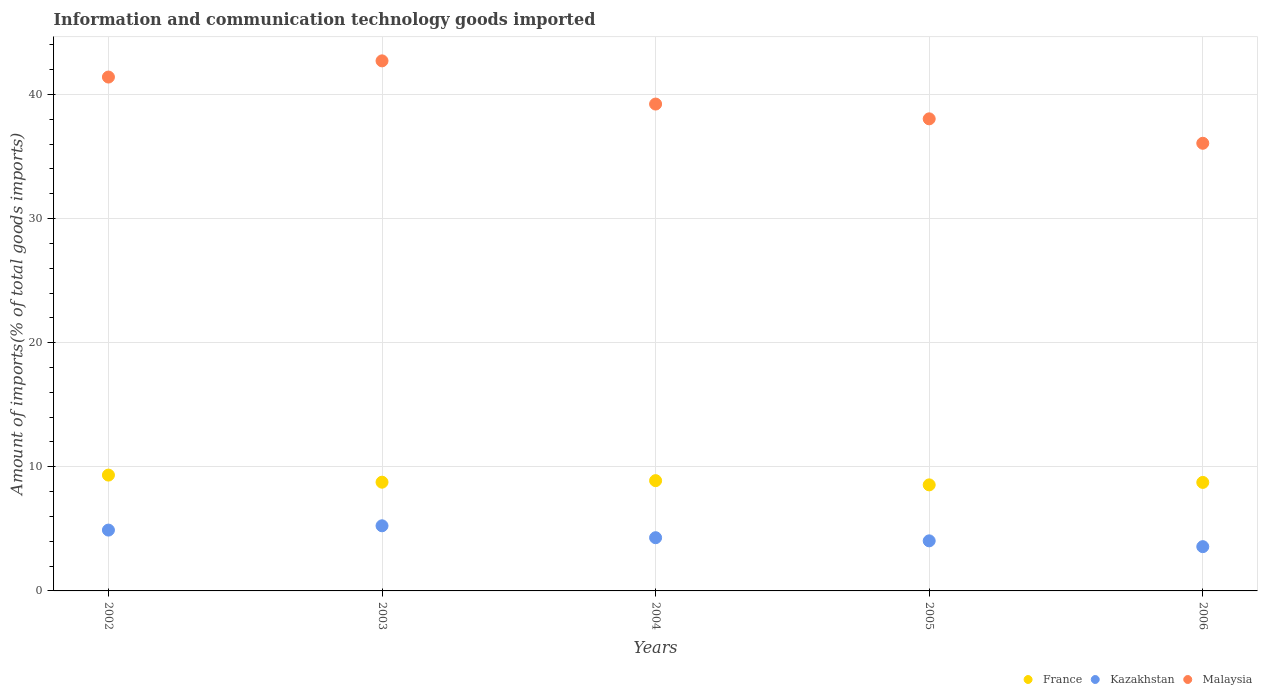How many different coloured dotlines are there?
Your answer should be very brief. 3. Is the number of dotlines equal to the number of legend labels?
Provide a short and direct response. Yes. What is the amount of goods imported in Kazakhstan in 2004?
Keep it short and to the point. 4.29. Across all years, what is the maximum amount of goods imported in Kazakhstan?
Your answer should be very brief. 5.25. Across all years, what is the minimum amount of goods imported in France?
Keep it short and to the point. 8.54. In which year was the amount of goods imported in France maximum?
Ensure brevity in your answer.  2002. In which year was the amount of goods imported in Kazakhstan minimum?
Make the answer very short. 2006. What is the total amount of goods imported in Kazakhstan in the graph?
Offer a very short reply. 22.04. What is the difference between the amount of goods imported in France in 2002 and that in 2003?
Give a very brief answer. 0.57. What is the difference between the amount of goods imported in France in 2003 and the amount of goods imported in Malaysia in 2005?
Your answer should be very brief. -29.28. What is the average amount of goods imported in France per year?
Keep it short and to the point. 8.85. In the year 2005, what is the difference between the amount of goods imported in France and amount of goods imported in Malaysia?
Keep it short and to the point. -29.49. In how many years, is the amount of goods imported in Kazakhstan greater than 6 %?
Provide a short and direct response. 0. What is the ratio of the amount of goods imported in France in 2003 to that in 2006?
Your answer should be compact. 1. Is the amount of goods imported in Kazakhstan in 2002 less than that in 2006?
Provide a short and direct response. No. What is the difference between the highest and the second highest amount of goods imported in Kazakhstan?
Keep it short and to the point. 0.35. What is the difference between the highest and the lowest amount of goods imported in Kazakhstan?
Provide a short and direct response. 1.68. In how many years, is the amount of goods imported in Kazakhstan greater than the average amount of goods imported in Kazakhstan taken over all years?
Make the answer very short. 2. Is it the case that in every year, the sum of the amount of goods imported in Malaysia and amount of goods imported in Kazakhstan  is greater than the amount of goods imported in France?
Make the answer very short. Yes. Does the amount of goods imported in France monotonically increase over the years?
Offer a very short reply. No. Is the amount of goods imported in Kazakhstan strictly greater than the amount of goods imported in Malaysia over the years?
Ensure brevity in your answer.  No. How many years are there in the graph?
Ensure brevity in your answer.  5. What is the difference between two consecutive major ticks on the Y-axis?
Your answer should be compact. 10. Does the graph contain grids?
Provide a succinct answer. Yes. Where does the legend appear in the graph?
Offer a very short reply. Bottom right. What is the title of the graph?
Keep it short and to the point. Information and communication technology goods imported. Does "France" appear as one of the legend labels in the graph?
Provide a short and direct response. Yes. What is the label or title of the X-axis?
Ensure brevity in your answer.  Years. What is the label or title of the Y-axis?
Keep it short and to the point. Amount of imports(% of total goods imports). What is the Amount of imports(% of total goods imports) in France in 2002?
Provide a succinct answer. 9.33. What is the Amount of imports(% of total goods imports) in Kazakhstan in 2002?
Make the answer very short. 4.9. What is the Amount of imports(% of total goods imports) of Malaysia in 2002?
Offer a terse response. 41.4. What is the Amount of imports(% of total goods imports) of France in 2003?
Your answer should be compact. 8.76. What is the Amount of imports(% of total goods imports) of Kazakhstan in 2003?
Offer a very short reply. 5.25. What is the Amount of imports(% of total goods imports) of Malaysia in 2003?
Offer a very short reply. 42.71. What is the Amount of imports(% of total goods imports) of France in 2004?
Your answer should be compact. 8.89. What is the Amount of imports(% of total goods imports) in Kazakhstan in 2004?
Give a very brief answer. 4.29. What is the Amount of imports(% of total goods imports) of Malaysia in 2004?
Ensure brevity in your answer.  39.23. What is the Amount of imports(% of total goods imports) in France in 2005?
Offer a very short reply. 8.54. What is the Amount of imports(% of total goods imports) of Kazakhstan in 2005?
Your answer should be compact. 4.03. What is the Amount of imports(% of total goods imports) of Malaysia in 2005?
Offer a terse response. 38.04. What is the Amount of imports(% of total goods imports) of France in 2006?
Your response must be concise. 8.74. What is the Amount of imports(% of total goods imports) in Kazakhstan in 2006?
Provide a short and direct response. 3.57. What is the Amount of imports(% of total goods imports) in Malaysia in 2006?
Keep it short and to the point. 36.07. Across all years, what is the maximum Amount of imports(% of total goods imports) of France?
Make the answer very short. 9.33. Across all years, what is the maximum Amount of imports(% of total goods imports) in Kazakhstan?
Keep it short and to the point. 5.25. Across all years, what is the maximum Amount of imports(% of total goods imports) in Malaysia?
Your answer should be compact. 42.71. Across all years, what is the minimum Amount of imports(% of total goods imports) of France?
Keep it short and to the point. 8.54. Across all years, what is the minimum Amount of imports(% of total goods imports) in Kazakhstan?
Keep it short and to the point. 3.57. Across all years, what is the minimum Amount of imports(% of total goods imports) of Malaysia?
Your answer should be very brief. 36.07. What is the total Amount of imports(% of total goods imports) of France in the graph?
Provide a succinct answer. 44.27. What is the total Amount of imports(% of total goods imports) in Kazakhstan in the graph?
Your answer should be very brief. 22.04. What is the total Amount of imports(% of total goods imports) of Malaysia in the graph?
Provide a succinct answer. 197.45. What is the difference between the Amount of imports(% of total goods imports) of France in 2002 and that in 2003?
Keep it short and to the point. 0.57. What is the difference between the Amount of imports(% of total goods imports) in Kazakhstan in 2002 and that in 2003?
Your response must be concise. -0.35. What is the difference between the Amount of imports(% of total goods imports) in Malaysia in 2002 and that in 2003?
Make the answer very short. -1.3. What is the difference between the Amount of imports(% of total goods imports) of France in 2002 and that in 2004?
Provide a succinct answer. 0.45. What is the difference between the Amount of imports(% of total goods imports) of Kazakhstan in 2002 and that in 2004?
Your answer should be very brief. 0.61. What is the difference between the Amount of imports(% of total goods imports) in Malaysia in 2002 and that in 2004?
Make the answer very short. 2.18. What is the difference between the Amount of imports(% of total goods imports) of France in 2002 and that in 2005?
Your answer should be compact. 0.79. What is the difference between the Amount of imports(% of total goods imports) in Kazakhstan in 2002 and that in 2005?
Your answer should be compact. 0.87. What is the difference between the Amount of imports(% of total goods imports) of Malaysia in 2002 and that in 2005?
Your response must be concise. 3.37. What is the difference between the Amount of imports(% of total goods imports) in France in 2002 and that in 2006?
Keep it short and to the point. 0.59. What is the difference between the Amount of imports(% of total goods imports) of Kazakhstan in 2002 and that in 2006?
Give a very brief answer. 1.33. What is the difference between the Amount of imports(% of total goods imports) in Malaysia in 2002 and that in 2006?
Keep it short and to the point. 5.34. What is the difference between the Amount of imports(% of total goods imports) of France in 2003 and that in 2004?
Provide a succinct answer. -0.12. What is the difference between the Amount of imports(% of total goods imports) in Kazakhstan in 2003 and that in 2004?
Keep it short and to the point. 0.96. What is the difference between the Amount of imports(% of total goods imports) of Malaysia in 2003 and that in 2004?
Provide a succinct answer. 3.48. What is the difference between the Amount of imports(% of total goods imports) in France in 2003 and that in 2005?
Your answer should be very brief. 0.22. What is the difference between the Amount of imports(% of total goods imports) of Kazakhstan in 2003 and that in 2005?
Your answer should be very brief. 1.21. What is the difference between the Amount of imports(% of total goods imports) in Malaysia in 2003 and that in 2005?
Provide a short and direct response. 4.67. What is the difference between the Amount of imports(% of total goods imports) of France in 2003 and that in 2006?
Provide a succinct answer. 0.02. What is the difference between the Amount of imports(% of total goods imports) of Kazakhstan in 2003 and that in 2006?
Your response must be concise. 1.68. What is the difference between the Amount of imports(% of total goods imports) in Malaysia in 2003 and that in 2006?
Provide a succinct answer. 6.64. What is the difference between the Amount of imports(% of total goods imports) of France in 2004 and that in 2005?
Ensure brevity in your answer.  0.34. What is the difference between the Amount of imports(% of total goods imports) in Kazakhstan in 2004 and that in 2005?
Provide a short and direct response. 0.25. What is the difference between the Amount of imports(% of total goods imports) of Malaysia in 2004 and that in 2005?
Offer a terse response. 1.19. What is the difference between the Amount of imports(% of total goods imports) of France in 2004 and that in 2006?
Ensure brevity in your answer.  0.14. What is the difference between the Amount of imports(% of total goods imports) in Kazakhstan in 2004 and that in 2006?
Provide a succinct answer. 0.72. What is the difference between the Amount of imports(% of total goods imports) of Malaysia in 2004 and that in 2006?
Your answer should be very brief. 3.16. What is the difference between the Amount of imports(% of total goods imports) of France in 2005 and that in 2006?
Your answer should be compact. -0.2. What is the difference between the Amount of imports(% of total goods imports) of Kazakhstan in 2005 and that in 2006?
Provide a short and direct response. 0.47. What is the difference between the Amount of imports(% of total goods imports) in Malaysia in 2005 and that in 2006?
Provide a short and direct response. 1.97. What is the difference between the Amount of imports(% of total goods imports) of France in 2002 and the Amount of imports(% of total goods imports) of Kazakhstan in 2003?
Offer a terse response. 4.09. What is the difference between the Amount of imports(% of total goods imports) of France in 2002 and the Amount of imports(% of total goods imports) of Malaysia in 2003?
Offer a terse response. -33.38. What is the difference between the Amount of imports(% of total goods imports) in Kazakhstan in 2002 and the Amount of imports(% of total goods imports) in Malaysia in 2003?
Provide a short and direct response. -37.81. What is the difference between the Amount of imports(% of total goods imports) in France in 2002 and the Amount of imports(% of total goods imports) in Kazakhstan in 2004?
Offer a terse response. 5.05. What is the difference between the Amount of imports(% of total goods imports) of France in 2002 and the Amount of imports(% of total goods imports) of Malaysia in 2004?
Offer a very short reply. -29.9. What is the difference between the Amount of imports(% of total goods imports) in Kazakhstan in 2002 and the Amount of imports(% of total goods imports) in Malaysia in 2004?
Provide a short and direct response. -34.33. What is the difference between the Amount of imports(% of total goods imports) of France in 2002 and the Amount of imports(% of total goods imports) of Kazakhstan in 2005?
Make the answer very short. 5.3. What is the difference between the Amount of imports(% of total goods imports) of France in 2002 and the Amount of imports(% of total goods imports) of Malaysia in 2005?
Offer a terse response. -28.7. What is the difference between the Amount of imports(% of total goods imports) of Kazakhstan in 2002 and the Amount of imports(% of total goods imports) of Malaysia in 2005?
Give a very brief answer. -33.14. What is the difference between the Amount of imports(% of total goods imports) of France in 2002 and the Amount of imports(% of total goods imports) of Kazakhstan in 2006?
Offer a terse response. 5.77. What is the difference between the Amount of imports(% of total goods imports) in France in 2002 and the Amount of imports(% of total goods imports) in Malaysia in 2006?
Your answer should be compact. -26.74. What is the difference between the Amount of imports(% of total goods imports) in Kazakhstan in 2002 and the Amount of imports(% of total goods imports) in Malaysia in 2006?
Give a very brief answer. -31.17. What is the difference between the Amount of imports(% of total goods imports) of France in 2003 and the Amount of imports(% of total goods imports) of Kazakhstan in 2004?
Keep it short and to the point. 4.47. What is the difference between the Amount of imports(% of total goods imports) in France in 2003 and the Amount of imports(% of total goods imports) in Malaysia in 2004?
Ensure brevity in your answer.  -30.47. What is the difference between the Amount of imports(% of total goods imports) of Kazakhstan in 2003 and the Amount of imports(% of total goods imports) of Malaysia in 2004?
Offer a terse response. -33.98. What is the difference between the Amount of imports(% of total goods imports) of France in 2003 and the Amount of imports(% of total goods imports) of Kazakhstan in 2005?
Keep it short and to the point. 4.73. What is the difference between the Amount of imports(% of total goods imports) in France in 2003 and the Amount of imports(% of total goods imports) in Malaysia in 2005?
Your answer should be compact. -29.28. What is the difference between the Amount of imports(% of total goods imports) of Kazakhstan in 2003 and the Amount of imports(% of total goods imports) of Malaysia in 2005?
Your response must be concise. -32.79. What is the difference between the Amount of imports(% of total goods imports) of France in 2003 and the Amount of imports(% of total goods imports) of Kazakhstan in 2006?
Offer a terse response. 5.19. What is the difference between the Amount of imports(% of total goods imports) in France in 2003 and the Amount of imports(% of total goods imports) in Malaysia in 2006?
Make the answer very short. -27.31. What is the difference between the Amount of imports(% of total goods imports) of Kazakhstan in 2003 and the Amount of imports(% of total goods imports) of Malaysia in 2006?
Your answer should be compact. -30.82. What is the difference between the Amount of imports(% of total goods imports) of France in 2004 and the Amount of imports(% of total goods imports) of Kazakhstan in 2005?
Offer a very short reply. 4.85. What is the difference between the Amount of imports(% of total goods imports) of France in 2004 and the Amount of imports(% of total goods imports) of Malaysia in 2005?
Offer a terse response. -29.15. What is the difference between the Amount of imports(% of total goods imports) in Kazakhstan in 2004 and the Amount of imports(% of total goods imports) in Malaysia in 2005?
Ensure brevity in your answer.  -33.75. What is the difference between the Amount of imports(% of total goods imports) in France in 2004 and the Amount of imports(% of total goods imports) in Kazakhstan in 2006?
Offer a very short reply. 5.32. What is the difference between the Amount of imports(% of total goods imports) of France in 2004 and the Amount of imports(% of total goods imports) of Malaysia in 2006?
Make the answer very short. -27.18. What is the difference between the Amount of imports(% of total goods imports) in Kazakhstan in 2004 and the Amount of imports(% of total goods imports) in Malaysia in 2006?
Your answer should be compact. -31.78. What is the difference between the Amount of imports(% of total goods imports) in France in 2005 and the Amount of imports(% of total goods imports) in Kazakhstan in 2006?
Your answer should be compact. 4.98. What is the difference between the Amount of imports(% of total goods imports) of France in 2005 and the Amount of imports(% of total goods imports) of Malaysia in 2006?
Provide a short and direct response. -27.52. What is the difference between the Amount of imports(% of total goods imports) in Kazakhstan in 2005 and the Amount of imports(% of total goods imports) in Malaysia in 2006?
Provide a short and direct response. -32.03. What is the average Amount of imports(% of total goods imports) in France per year?
Offer a terse response. 8.85. What is the average Amount of imports(% of total goods imports) in Kazakhstan per year?
Your answer should be compact. 4.41. What is the average Amount of imports(% of total goods imports) in Malaysia per year?
Give a very brief answer. 39.49. In the year 2002, what is the difference between the Amount of imports(% of total goods imports) of France and Amount of imports(% of total goods imports) of Kazakhstan?
Ensure brevity in your answer.  4.43. In the year 2002, what is the difference between the Amount of imports(% of total goods imports) of France and Amount of imports(% of total goods imports) of Malaysia?
Offer a terse response. -32.07. In the year 2002, what is the difference between the Amount of imports(% of total goods imports) in Kazakhstan and Amount of imports(% of total goods imports) in Malaysia?
Make the answer very short. -36.5. In the year 2003, what is the difference between the Amount of imports(% of total goods imports) in France and Amount of imports(% of total goods imports) in Kazakhstan?
Give a very brief answer. 3.51. In the year 2003, what is the difference between the Amount of imports(% of total goods imports) in France and Amount of imports(% of total goods imports) in Malaysia?
Offer a terse response. -33.95. In the year 2003, what is the difference between the Amount of imports(% of total goods imports) of Kazakhstan and Amount of imports(% of total goods imports) of Malaysia?
Offer a very short reply. -37.46. In the year 2004, what is the difference between the Amount of imports(% of total goods imports) in France and Amount of imports(% of total goods imports) in Kazakhstan?
Ensure brevity in your answer.  4.6. In the year 2004, what is the difference between the Amount of imports(% of total goods imports) of France and Amount of imports(% of total goods imports) of Malaysia?
Your answer should be compact. -30.34. In the year 2004, what is the difference between the Amount of imports(% of total goods imports) of Kazakhstan and Amount of imports(% of total goods imports) of Malaysia?
Your response must be concise. -34.94. In the year 2005, what is the difference between the Amount of imports(% of total goods imports) of France and Amount of imports(% of total goods imports) of Kazakhstan?
Offer a very short reply. 4.51. In the year 2005, what is the difference between the Amount of imports(% of total goods imports) of France and Amount of imports(% of total goods imports) of Malaysia?
Keep it short and to the point. -29.49. In the year 2005, what is the difference between the Amount of imports(% of total goods imports) in Kazakhstan and Amount of imports(% of total goods imports) in Malaysia?
Ensure brevity in your answer.  -34. In the year 2006, what is the difference between the Amount of imports(% of total goods imports) of France and Amount of imports(% of total goods imports) of Kazakhstan?
Give a very brief answer. 5.18. In the year 2006, what is the difference between the Amount of imports(% of total goods imports) of France and Amount of imports(% of total goods imports) of Malaysia?
Provide a short and direct response. -27.33. In the year 2006, what is the difference between the Amount of imports(% of total goods imports) in Kazakhstan and Amount of imports(% of total goods imports) in Malaysia?
Your answer should be very brief. -32.5. What is the ratio of the Amount of imports(% of total goods imports) of France in 2002 to that in 2003?
Your response must be concise. 1.07. What is the ratio of the Amount of imports(% of total goods imports) of Kazakhstan in 2002 to that in 2003?
Offer a very short reply. 0.93. What is the ratio of the Amount of imports(% of total goods imports) in Malaysia in 2002 to that in 2003?
Provide a short and direct response. 0.97. What is the ratio of the Amount of imports(% of total goods imports) of France in 2002 to that in 2004?
Your response must be concise. 1.05. What is the ratio of the Amount of imports(% of total goods imports) in Kazakhstan in 2002 to that in 2004?
Offer a terse response. 1.14. What is the ratio of the Amount of imports(% of total goods imports) in Malaysia in 2002 to that in 2004?
Offer a terse response. 1.06. What is the ratio of the Amount of imports(% of total goods imports) of France in 2002 to that in 2005?
Provide a succinct answer. 1.09. What is the ratio of the Amount of imports(% of total goods imports) in Kazakhstan in 2002 to that in 2005?
Your answer should be very brief. 1.21. What is the ratio of the Amount of imports(% of total goods imports) in Malaysia in 2002 to that in 2005?
Offer a very short reply. 1.09. What is the ratio of the Amount of imports(% of total goods imports) in France in 2002 to that in 2006?
Provide a short and direct response. 1.07. What is the ratio of the Amount of imports(% of total goods imports) in Kazakhstan in 2002 to that in 2006?
Your response must be concise. 1.37. What is the ratio of the Amount of imports(% of total goods imports) of Malaysia in 2002 to that in 2006?
Give a very brief answer. 1.15. What is the ratio of the Amount of imports(% of total goods imports) in France in 2003 to that in 2004?
Offer a very short reply. 0.99. What is the ratio of the Amount of imports(% of total goods imports) of Kazakhstan in 2003 to that in 2004?
Your answer should be compact. 1.22. What is the ratio of the Amount of imports(% of total goods imports) of Malaysia in 2003 to that in 2004?
Make the answer very short. 1.09. What is the ratio of the Amount of imports(% of total goods imports) of France in 2003 to that in 2005?
Your response must be concise. 1.03. What is the ratio of the Amount of imports(% of total goods imports) in Kazakhstan in 2003 to that in 2005?
Your response must be concise. 1.3. What is the ratio of the Amount of imports(% of total goods imports) of Malaysia in 2003 to that in 2005?
Offer a very short reply. 1.12. What is the ratio of the Amount of imports(% of total goods imports) in France in 2003 to that in 2006?
Provide a short and direct response. 1. What is the ratio of the Amount of imports(% of total goods imports) of Kazakhstan in 2003 to that in 2006?
Keep it short and to the point. 1.47. What is the ratio of the Amount of imports(% of total goods imports) in Malaysia in 2003 to that in 2006?
Your response must be concise. 1.18. What is the ratio of the Amount of imports(% of total goods imports) of France in 2004 to that in 2005?
Your answer should be very brief. 1.04. What is the ratio of the Amount of imports(% of total goods imports) in Kazakhstan in 2004 to that in 2005?
Your answer should be compact. 1.06. What is the ratio of the Amount of imports(% of total goods imports) in Malaysia in 2004 to that in 2005?
Your answer should be very brief. 1.03. What is the ratio of the Amount of imports(% of total goods imports) in France in 2004 to that in 2006?
Offer a terse response. 1.02. What is the ratio of the Amount of imports(% of total goods imports) in Kazakhstan in 2004 to that in 2006?
Provide a succinct answer. 1.2. What is the ratio of the Amount of imports(% of total goods imports) of Malaysia in 2004 to that in 2006?
Ensure brevity in your answer.  1.09. What is the ratio of the Amount of imports(% of total goods imports) of France in 2005 to that in 2006?
Make the answer very short. 0.98. What is the ratio of the Amount of imports(% of total goods imports) in Kazakhstan in 2005 to that in 2006?
Give a very brief answer. 1.13. What is the ratio of the Amount of imports(% of total goods imports) of Malaysia in 2005 to that in 2006?
Offer a very short reply. 1.05. What is the difference between the highest and the second highest Amount of imports(% of total goods imports) in France?
Your answer should be very brief. 0.45. What is the difference between the highest and the second highest Amount of imports(% of total goods imports) in Kazakhstan?
Provide a short and direct response. 0.35. What is the difference between the highest and the second highest Amount of imports(% of total goods imports) of Malaysia?
Provide a short and direct response. 1.3. What is the difference between the highest and the lowest Amount of imports(% of total goods imports) in France?
Your response must be concise. 0.79. What is the difference between the highest and the lowest Amount of imports(% of total goods imports) in Kazakhstan?
Give a very brief answer. 1.68. What is the difference between the highest and the lowest Amount of imports(% of total goods imports) in Malaysia?
Give a very brief answer. 6.64. 